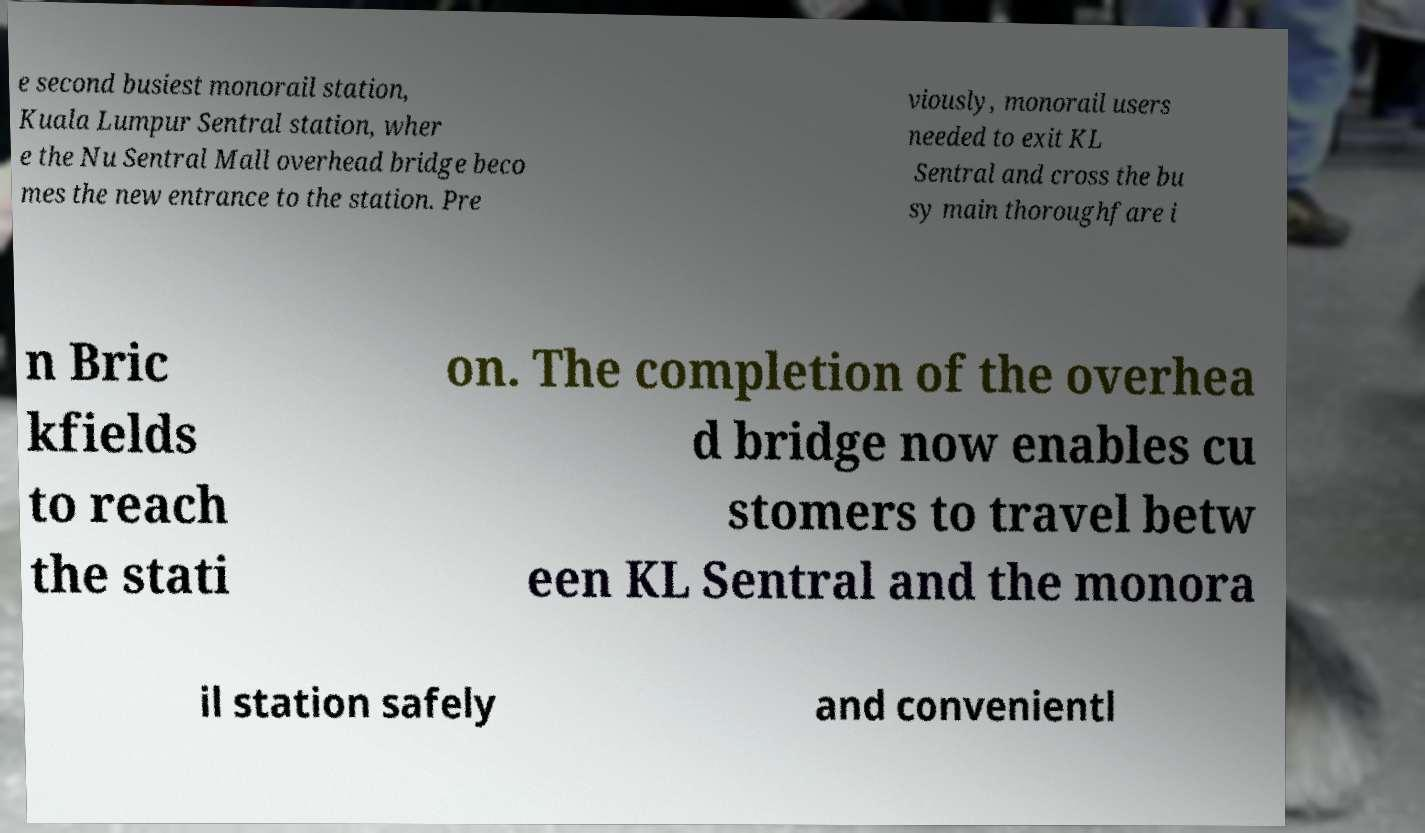Can you accurately transcribe the text from the provided image for me? e second busiest monorail station, Kuala Lumpur Sentral station, wher e the Nu Sentral Mall overhead bridge beco mes the new entrance to the station. Pre viously, monorail users needed to exit KL Sentral and cross the bu sy main thoroughfare i n Bric kfields to reach the stati on. The completion of the overhea d bridge now enables cu stomers to travel betw een KL Sentral and the monora il station safely and convenientl 